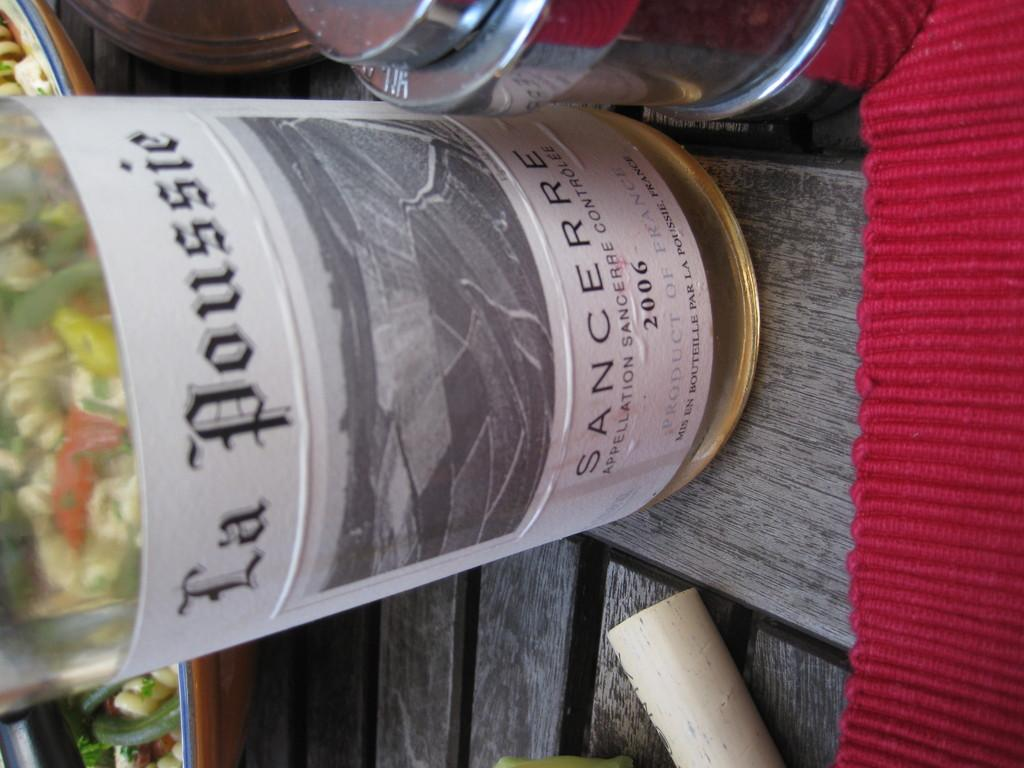<image>
Render a clear and concise summary of the photo. A label reads La Poussie SANCERRE on a bottle of French wine. 